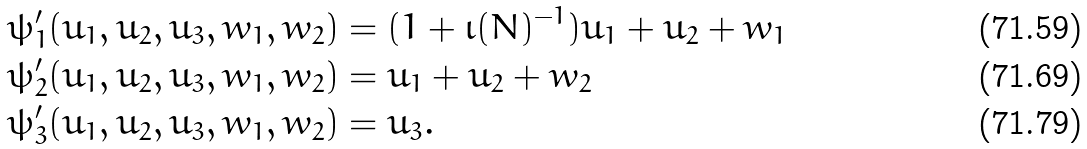<formula> <loc_0><loc_0><loc_500><loc_500>\psi ^ { \prime } _ { 1 } ( u _ { 1 } , u _ { 2 } , u _ { 3 } , w _ { 1 } , w _ { 2 } ) & = ( 1 + \iota ( N ) ^ { - 1 } ) u _ { 1 } + u _ { 2 } + w _ { 1 } \\ \psi ^ { \prime } _ { 2 } ( u _ { 1 } , u _ { 2 } , u _ { 3 } , w _ { 1 } , w _ { 2 } ) & = u _ { 1 } + u _ { 2 } + w _ { 2 } \\ \psi ^ { \prime } _ { 3 } ( u _ { 1 } , u _ { 2 } , u _ { 3 } , w _ { 1 } , w _ { 2 } ) & = u _ { 3 } .</formula> 